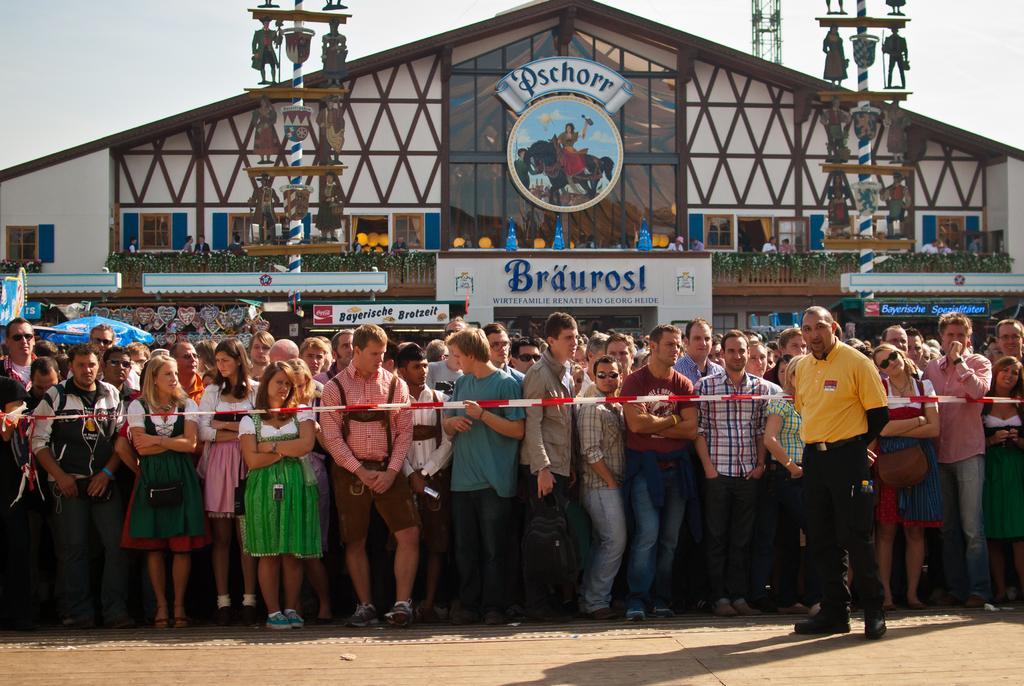Can you describe this image briefly? In the picture we can see a house and in front of it we can see many people are standing and in front of them we can see a ribbon and outside we can see a man standing and he is with yellow T-shirt and in the background we can see sky. 